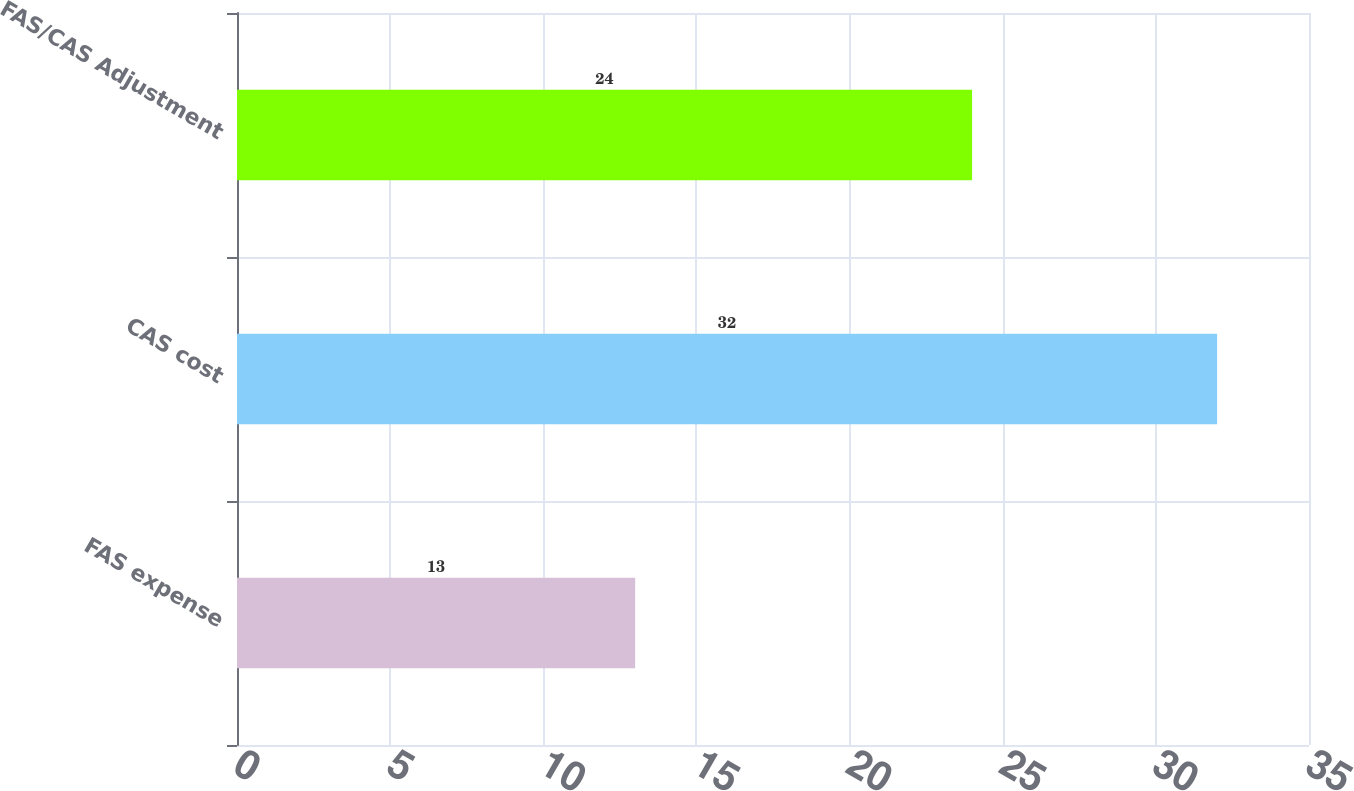Convert chart to OTSL. <chart><loc_0><loc_0><loc_500><loc_500><bar_chart><fcel>FAS expense<fcel>CAS cost<fcel>FAS/CAS Adjustment<nl><fcel>13<fcel>32<fcel>24<nl></chart> 